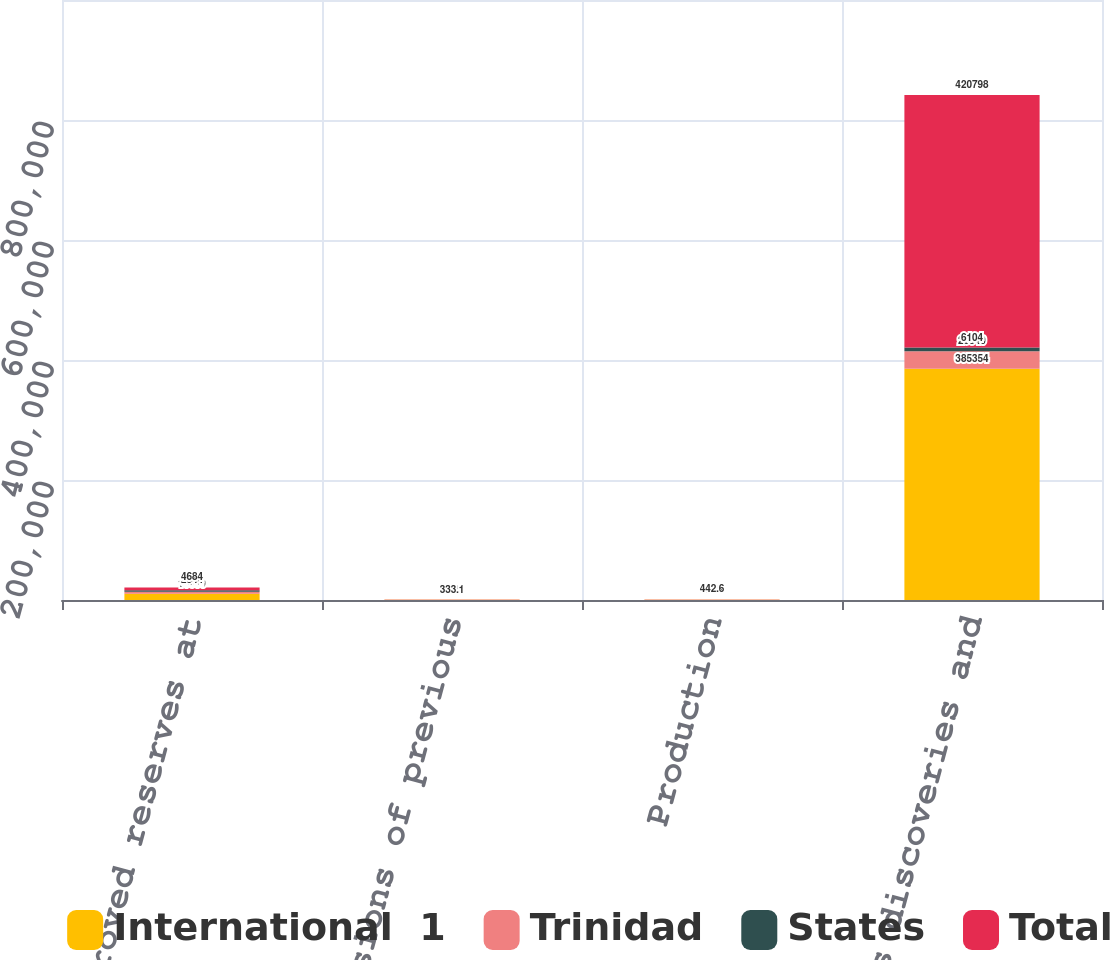Convert chart to OTSL. <chart><loc_0><loc_0><loc_500><loc_500><stacked_bar_chart><ecel><fcel>Net proved reserves at<fcel>Revisions of previous<fcel>Production<fcel>Extensions discoveries and<nl><fcel>International  1<fcel>10500<fcel>298.4<fcel>308.6<fcel>385354<nl><fcel>Trinidad<fcel>3272<fcel>29.5<fcel>125.1<fcel>29340<nl><fcel>States<fcel>2544<fcel>5.2<fcel>8.9<fcel>6104<nl><fcel>Total<fcel>4684<fcel>333.1<fcel>442.6<fcel>420798<nl></chart> 